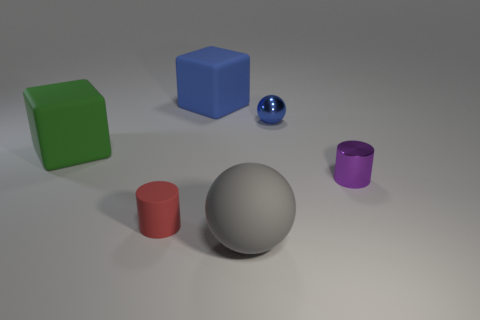How many tiny things are either gray spheres or red rubber things?
Offer a terse response. 1. Are there more tiny rubber objects that are left of the big green object than objects in front of the big blue thing?
Offer a terse response. No. Do the large sphere and the cube that is behind the blue ball have the same material?
Offer a very short reply. Yes. What is the color of the big matte ball?
Your answer should be compact. Gray. There is a small thing that is in front of the tiny purple object; what shape is it?
Keep it short and to the point. Cylinder. How many blue objects are either small matte cylinders or tiny things?
Provide a succinct answer. 1. There is a large ball that is made of the same material as the green thing; what is its color?
Your answer should be very brief. Gray. Do the tiny sphere and the rubber thing that is in front of the small red thing have the same color?
Make the answer very short. No. What is the color of the small object that is on the left side of the tiny metal cylinder and behind the small red thing?
Provide a succinct answer. Blue. There is a large gray object; how many tiny red objects are behind it?
Make the answer very short. 1. 